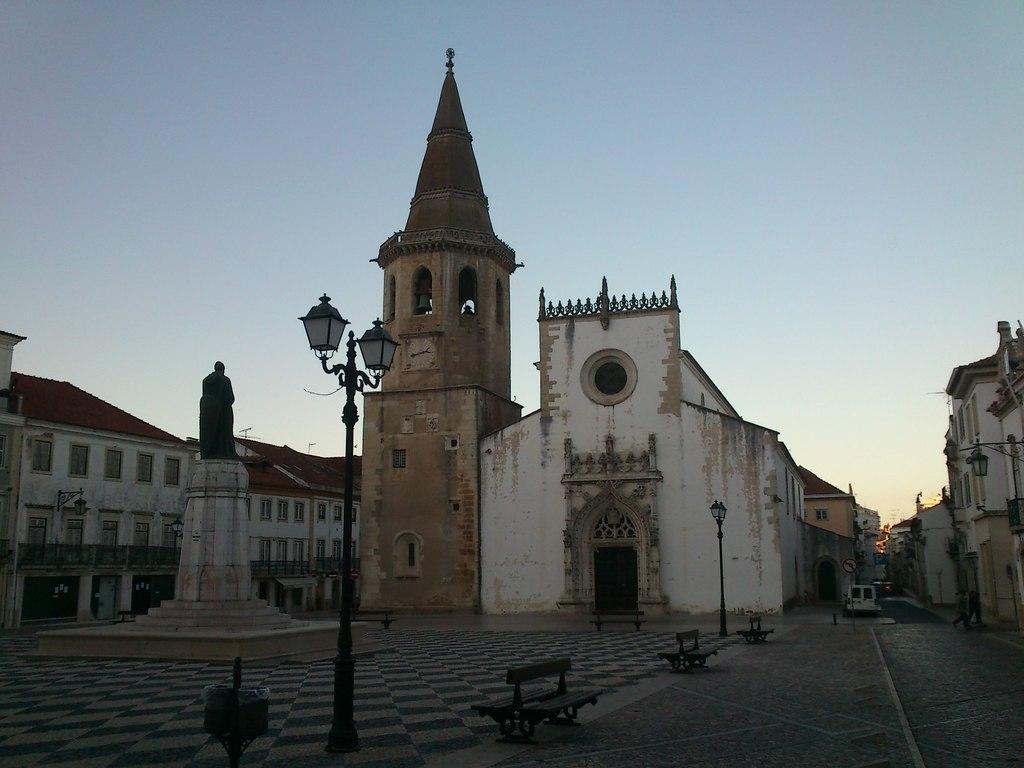In one or two sentences, can you explain what this image depicts? In this image I can see the benches and the light poles. To the left I can see the statue of the person. In the background I can see the buildings, vehicles and the sky. 